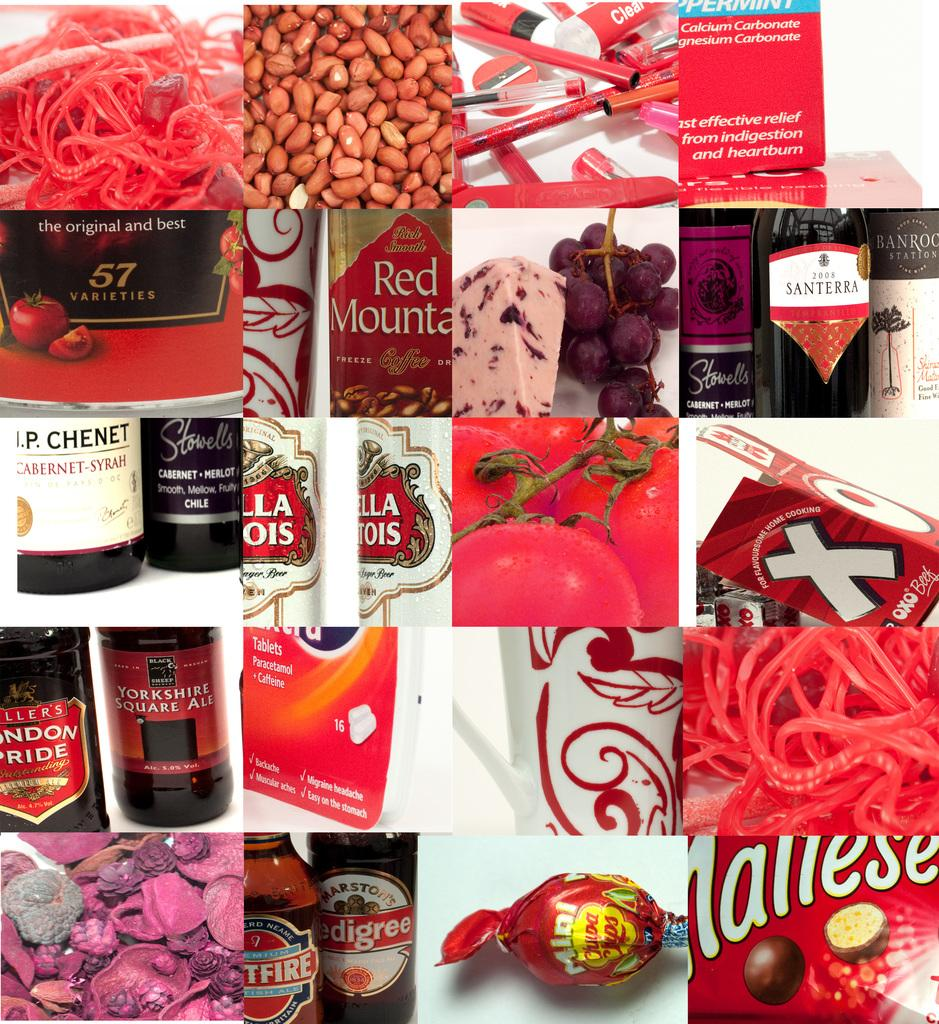<image>
Share a concise interpretation of the image provided. a collage of red objects like Red Mounta and 57 varieties 